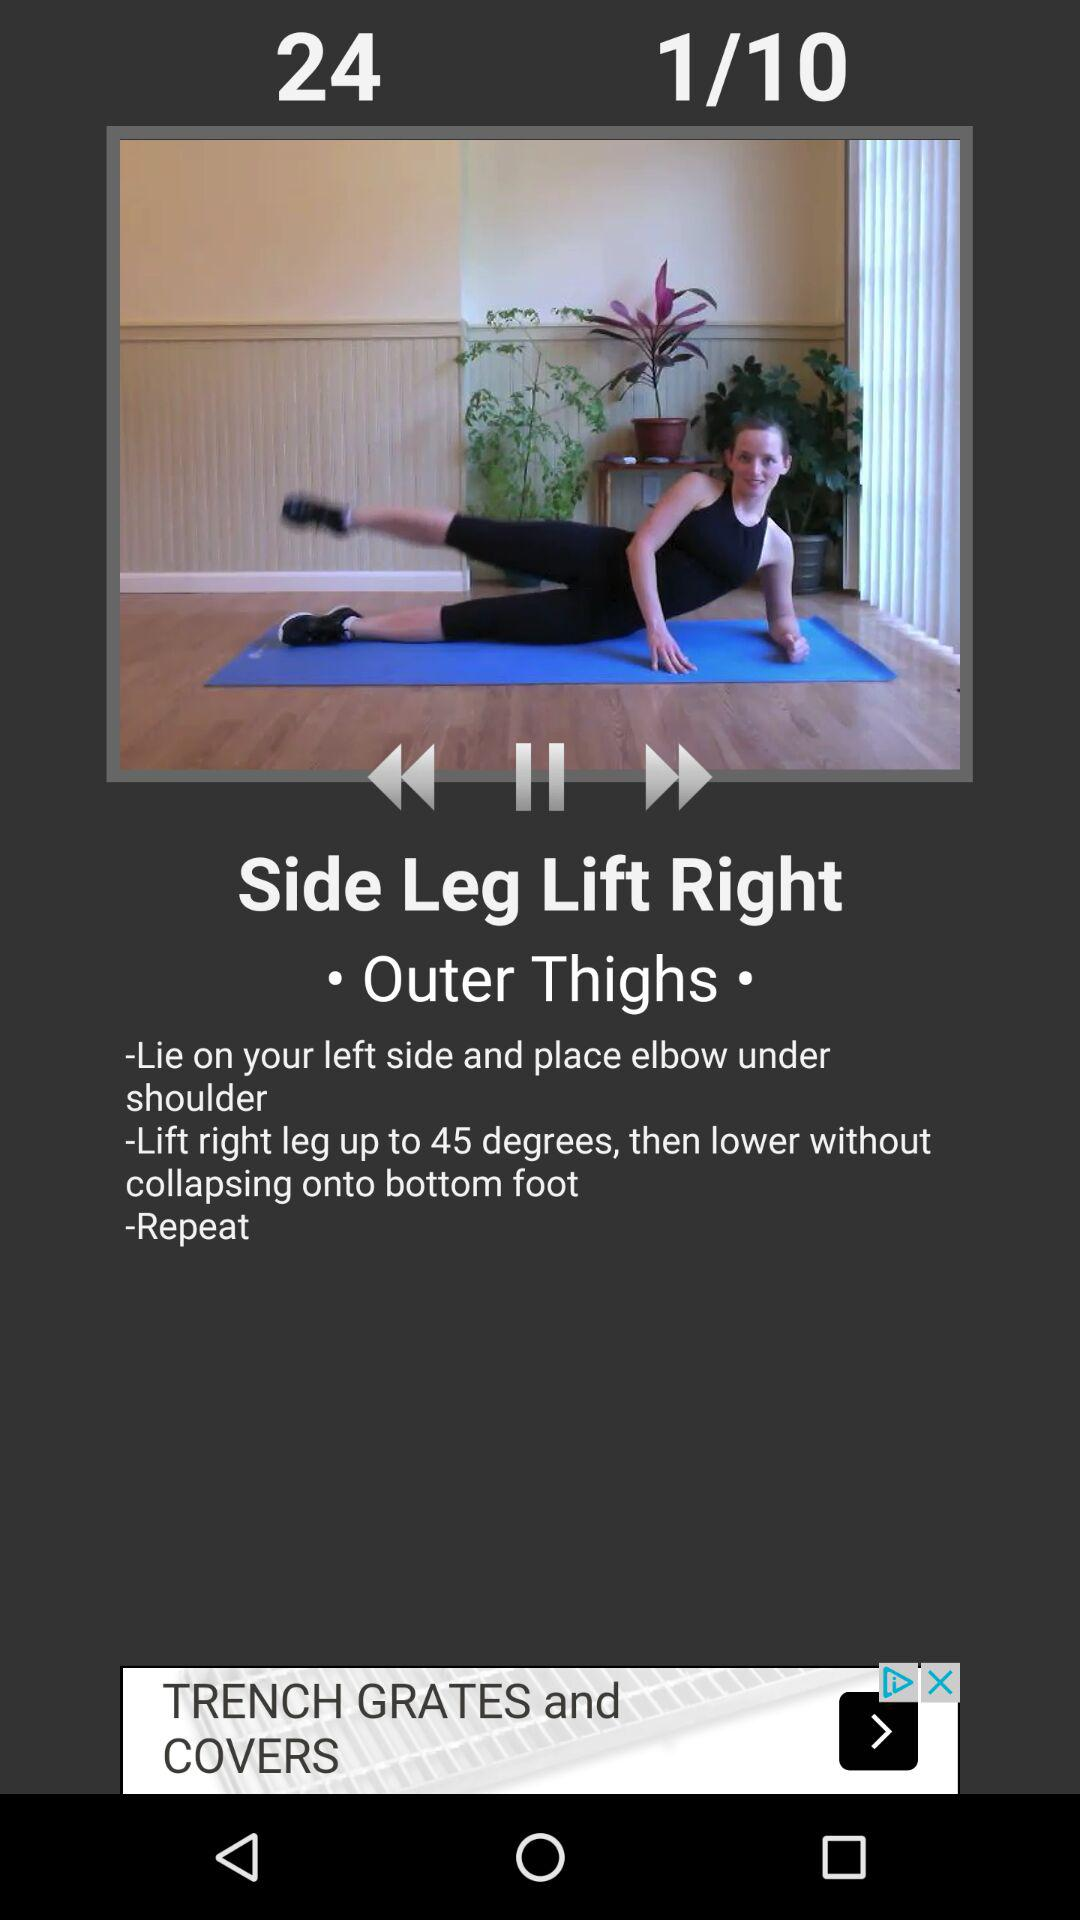How many degrees higher is the right leg lifted than the bottom foot?
Answer the question using a single word or phrase. 45 